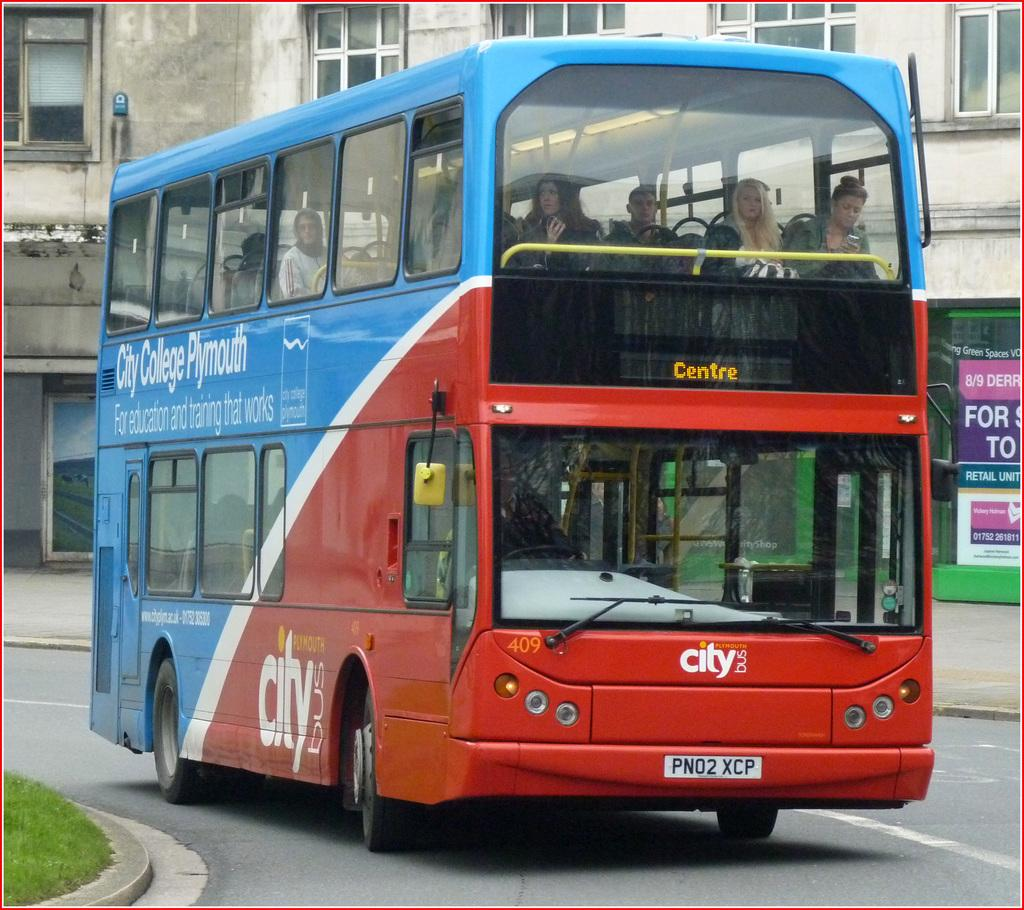What type of vehicle is in the image? There is a red and blue double-decker bus in the image. What is the bus doing in the image? The bus is moving on the road. What can be seen in the background of the image? There is a building with glass windows visible in the image. What type of map is the turkey holding in the image? There is no turkey or map present in the image; it features a red and blue double-decker bus moving on the road with a building in the background. 